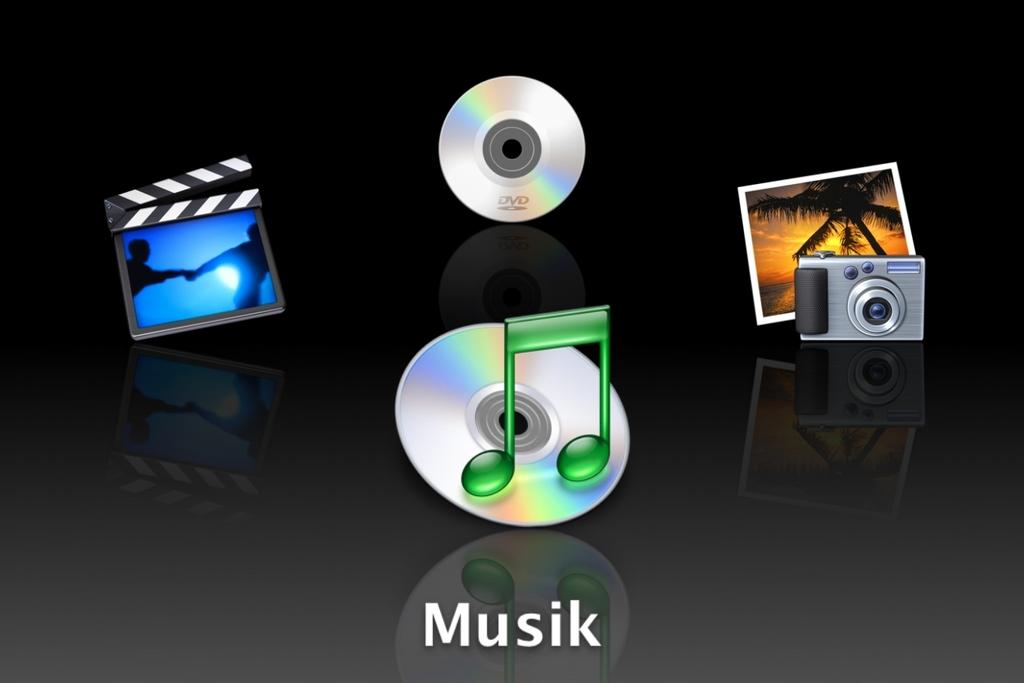What is the main subject of the image? The main subject of the image is a depiction of two disks. Are there any other objects or elements in the image? Yes, there is a photo, a camera, and other unspecified things in the image. Can you describe the writing on the bottom side of the image? Unfortunately, the facts provided do not specify the content of the writing on the bottom side of the image. What might the camera be used for in the image? The camera might be used for capturing the photo or other elements in the image. What type of animal can be seen playing in the snow in the image? There is no animal or snow present in the image; it features a depiction of two disks, a photo, a camera, and other unspecified things. How many stems are visible in the image? There is no mention of stems in the image; it features a depiction of two disks, a photo, a camera, and other unspecified things. 